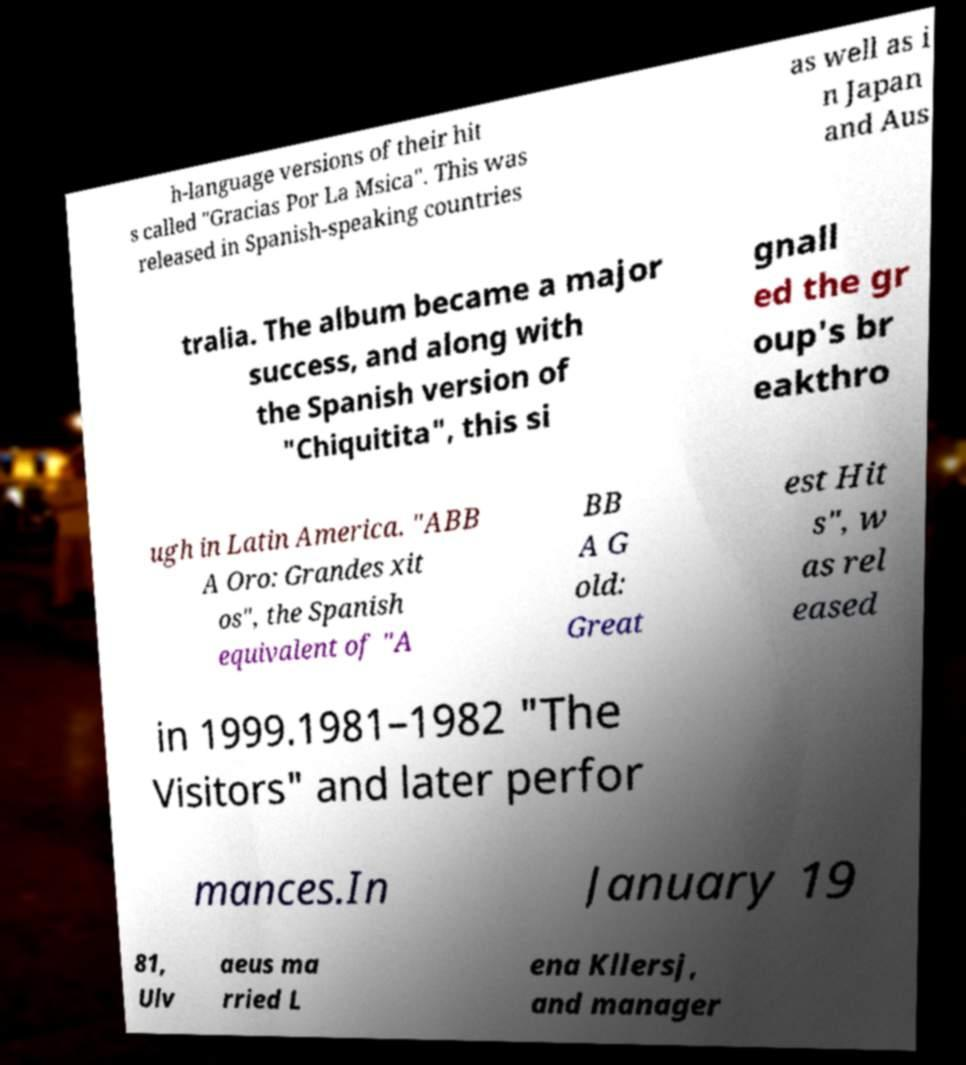There's text embedded in this image that I need extracted. Can you transcribe it verbatim? h-language versions of their hit s called "Gracias Por La Msica". This was released in Spanish-speaking countries as well as i n Japan and Aus tralia. The album became a major success, and along with the Spanish version of "Chiquitita", this si gnall ed the gr oup's br eakthro ugh in Latin America. "ABB A Oro: Grandes xit os", the Spanish equivalent of "A BB A G old: Great est Hit s", w as rel eased in 1999.1981–1982 "The Visitors" and later perfor mances.In January 19 81, Ulv aeus ma rried L ena Kllersj, and manager 